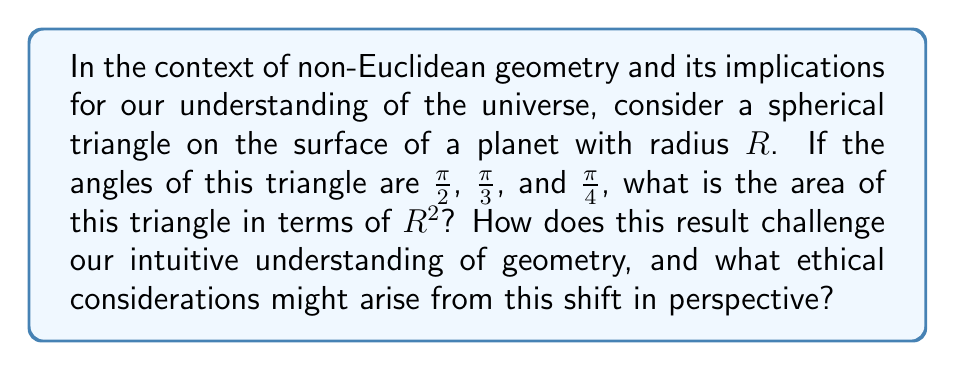Show me your answer to this math problem. 1) In spherical geometry, the area $A$ of a triangle is given by the formula:

   $$A = R^2(α + β + γ - π)$$

   where $R$ is the radius of the sphere, and $α$, $β$, and $γ$ are the angles of the triangle.

2) We are given the angles:
   $α = \frac{\pi}{2}$, $β = \frac{\pi}{3}$, and $γ = \frac{\pi}{4}$

3) Substituting these into the formula:

   $$A = R^2(\frac{\pi}{2} + \frac{\pi}{3} + \frac{\pi}{4} - π)$$

4) Simplifying:
   $$A = R^2(\frac{6π + 4π + 3π}{12} - π)$$
   $$A = R^2(\frac{13π}{12} - π)$$
   $$A = R^2(\frac{13π - 12π}{12})$$
   $$A = R^2(\frac{π}{12})$$

5) This result challenges our Euclidean intuition because:
   a) The sum of the angles is greater than π (180°).
   b) The area depends on the radius of the sphere, unlike in Euclidean geometry.

6) Ethical considerations:
   a) This shift in perspective challenges our assumptions about the nature of space and reality.
   b) It raises questions about the limits of human perception and understanding.
   c) It emphasizes the importance of considering multiple perspectives in ethical decision-making.
   d) It highlights the need for humility in scientific and philosophical inquiries.
Answer: $\frac{π}{12}R^2$ 